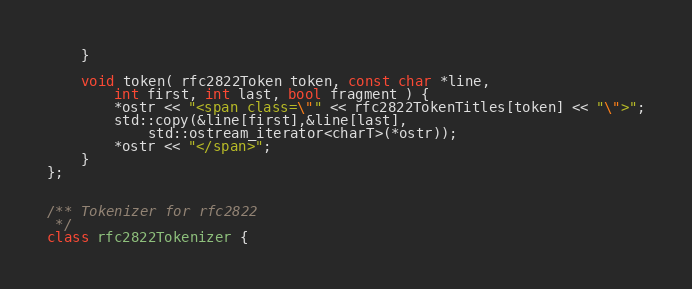<code> <loc_0><loc_0><loc_500><loc_500><_C++_>    }

    void token( rfc2822Token token, const char *line,
        int first, int last, bool fragment ) {
        *ostr << "<span class=\"" << rfc2822TokenTitles[token] << "\">";
        std::copy(&line[first],&line[last],
            std::ostream_iterator<charT>(*ostr));
        *ostr << "</span>";
    }
};


/** Tokenizer for rfc2822
 */
class rfc2822Tokenizer {</code> 